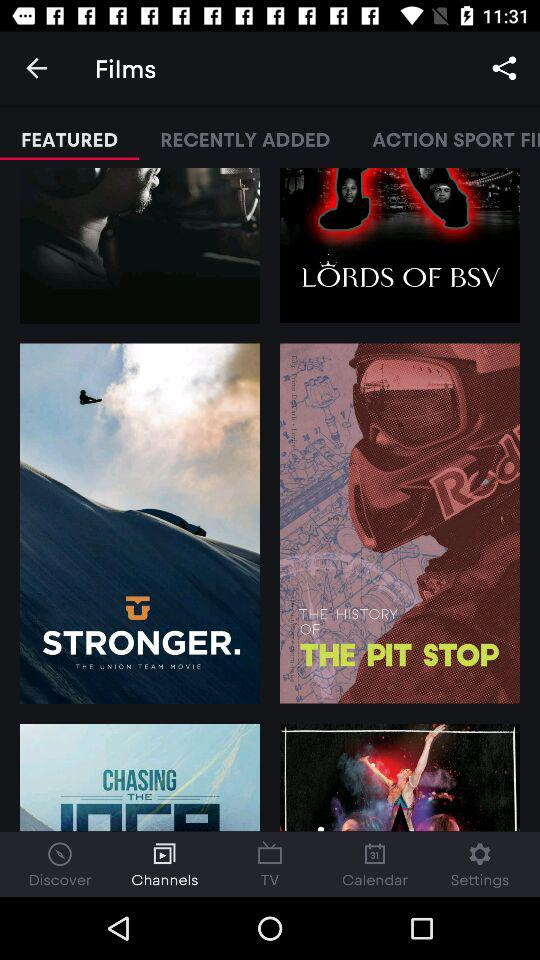Which option has been selected from the lower bar? The selected option is "Channels". 